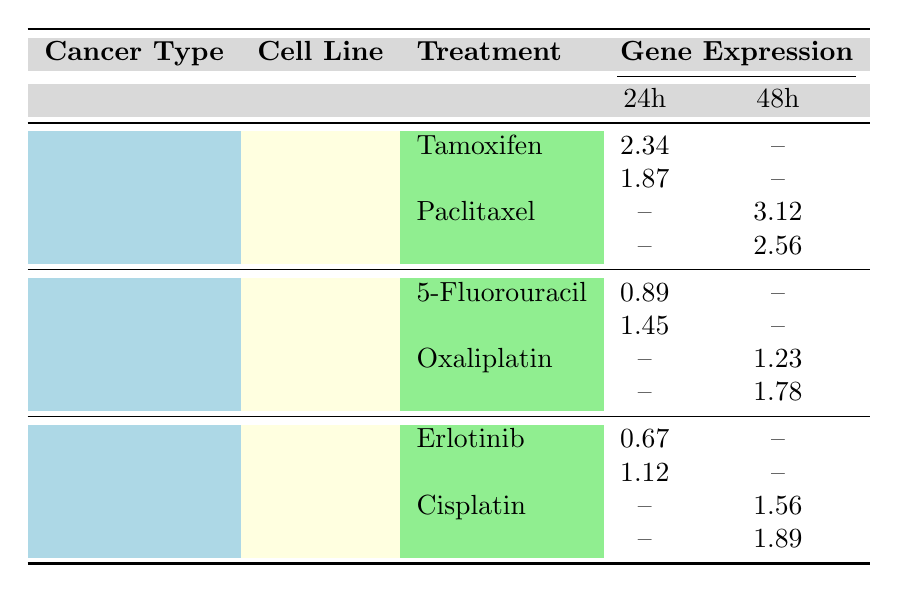What is the expression level of BRCA1 in MCF-7 cell line under Tamoxifen treatment at 24 hours? The table shows a specific entry for MCF-7 cell line under the treatment of Tamoxifen. The expression level for the gene BRCA1 at the 24-hour timepoint is listed as 2.34.
Answer: 2.34 What is the treatment used for HCT116 cell line at 48 hours for the KRAS gene? Looking at the table, the treatment listed for HCT116 cell line at 48 hours for the KRAS gene is Oxaliplatin, with an expression level of 1.78.
Answer: Oxaliplatin Is the expression level of TP53 higher in MCF-7 cell line treated with Paclitaxel or Tamoxifen? The expression level of TP53 under Paclitaxel treatment at 48 hours is 2.56, while under Tamoxifen at 24 hours it is 1.87. Comparing these, 2.56 is greater than 1.87.
Answer: Higher in Paclitaxel What are the average expression levels of gene EGFR for the A549 cell line across treatments and timepoints? The values for EGFR in A549 cell line are 0.67 at 24 hours (Erlotinib) and 1.56 at 48 hours (Cisplatin). The average is calculated as (0.67 + 1.56) / 2 = 1.115.
Answer: 1.115 Is the expression level of APC gene in HCT116 cell line treated with 5-Fluorouracil lower than that treated with Oxaliplatin? The expression level of APC under 5-Fluorouracil is 0.89 at 24 hours and under Oxaliplatin is 1.23 at 48 hours. Since 0.89 is less than 1.23, the statement is true.
Answer: Yes What is the total expression count for A549 cell line across all treatments? The expression levels for A549 are 0.67 (Erlotinib at 24h), 1.12 (Erlotinib at 24h), 1.56 (Cisplatin at 48h), and 1.89 (Cisplatin at 48h). Adding these values gives: 0.67 + 1.12 + 1.56 + 1.89 = 5.24.
Answer: 5.24 Which cancer type has the highest expression level for any gene at any timepoint? From the table, the highest expression levels are observed in the breast cancer type, specifically BRCA1 for MCF-7 under Paclitaxel treatment at 48 hours with a value of 3.12.
Answer: Breast Is there any gene in the Lung cancer type that has an expression level of greater than 1.5 at 48 hours? In the Lung cancer type (A549), the ALK gene shows an expression level of 1.89 at 48 hours, which is greater than 1.5. Therefore, the statement holds true.
Answer: Yes 